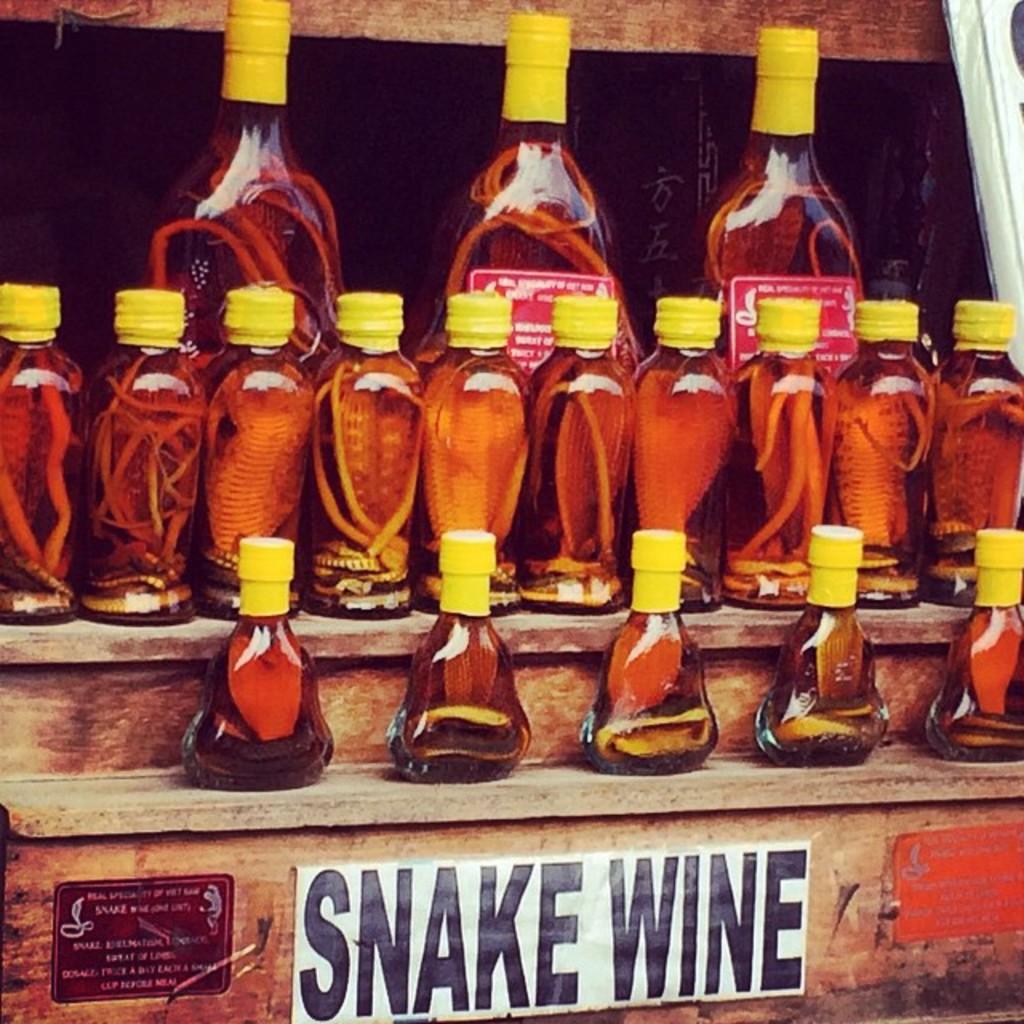What kind of wine is this?
Offer a terse response. Snake. What color are the words "snake wine"?
Your response must be concise. Black. 